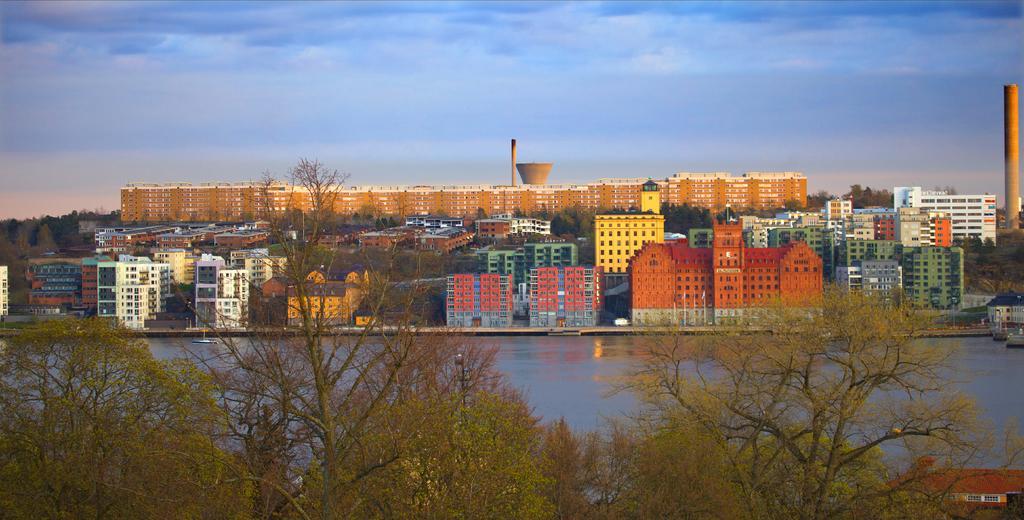Can you describe this image briefly? In this image in the foreground there are some trees and in the middle there are some buildings and the background is the sky. 